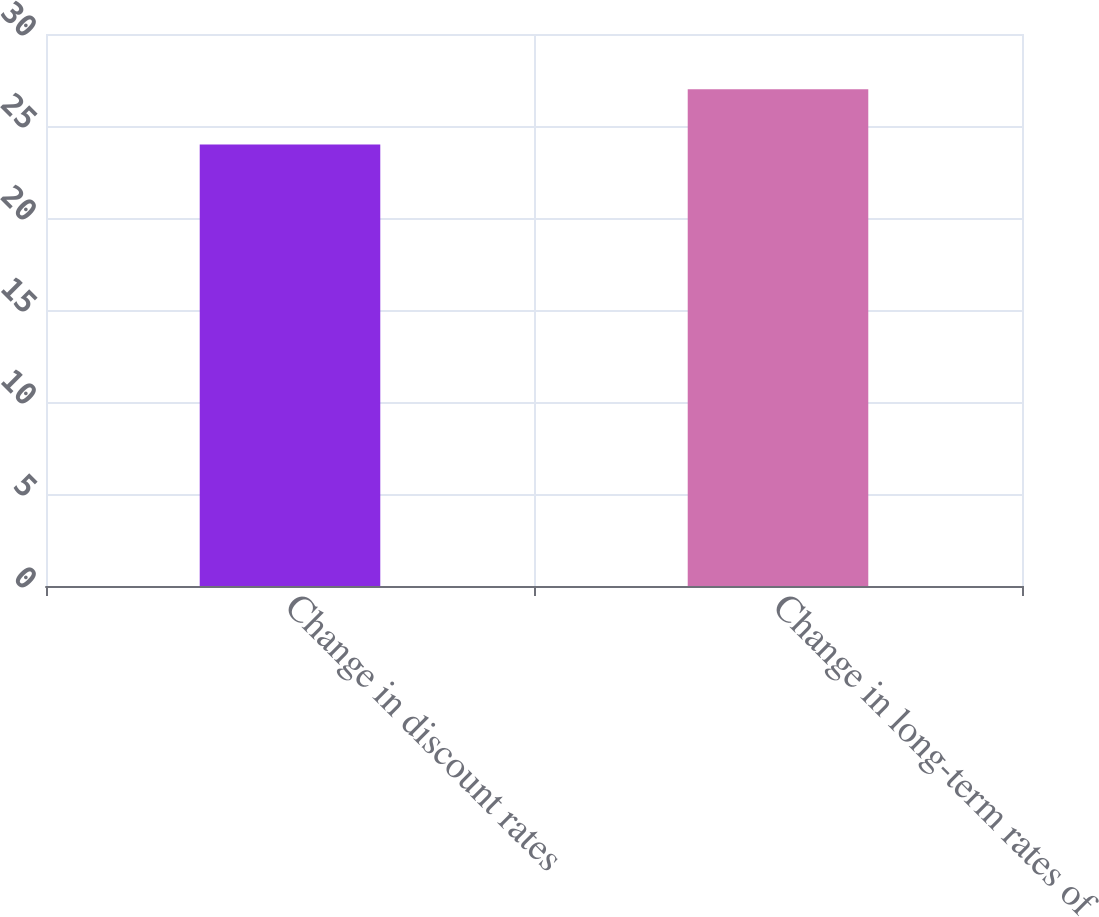Convert chart. <chart><loc_0><loc_0><loc_500><loc_500><bar_chart><fcel>Change in discount rates<fcel>Change in long-term rates of<nl><fcel>24<fcel>27<nl></chart> 